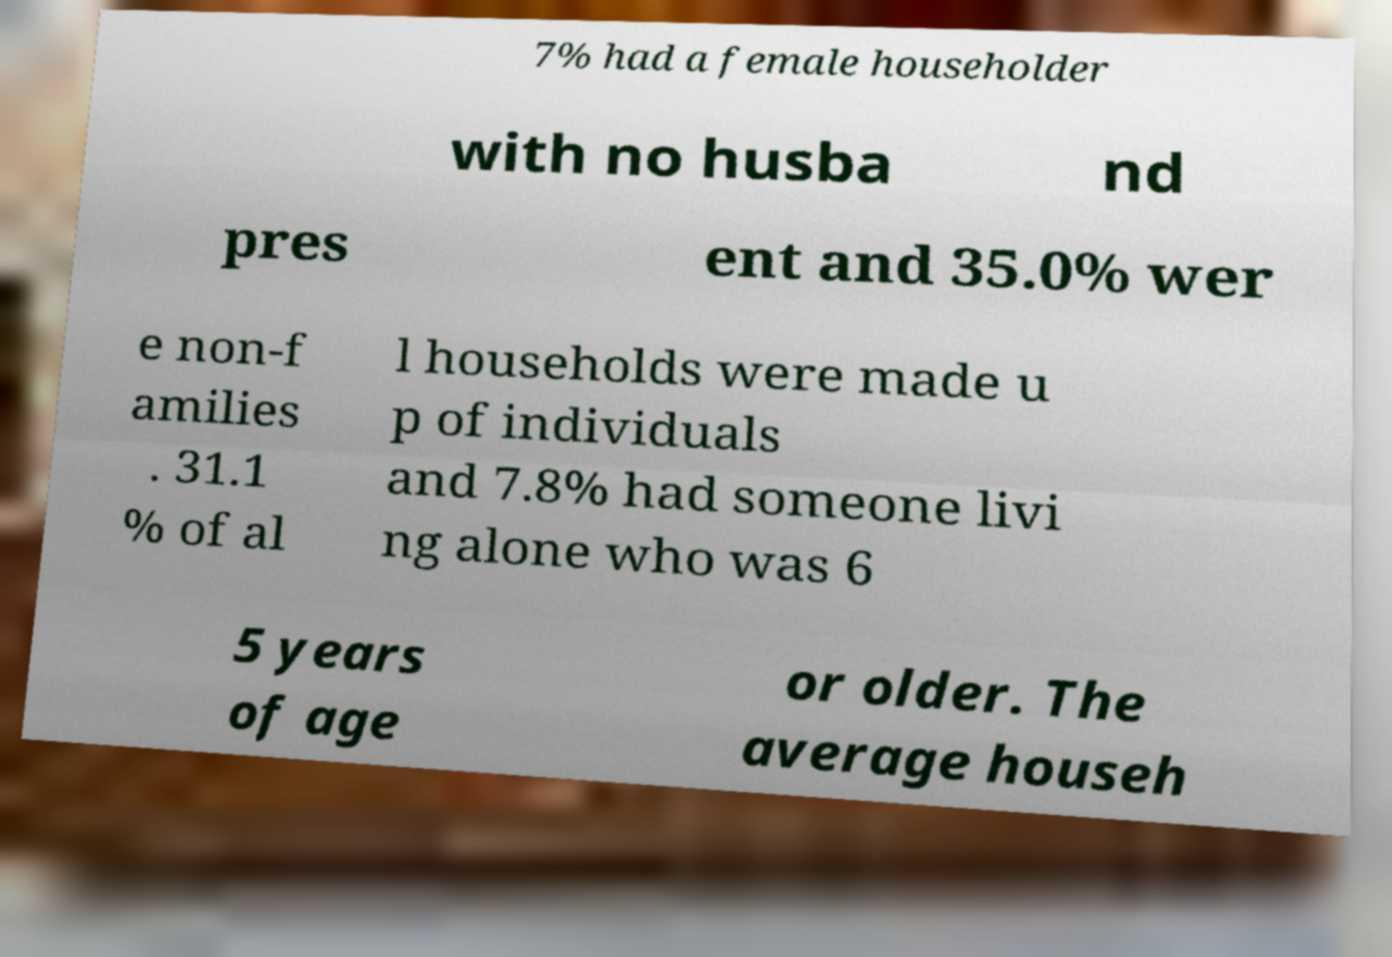Can you read and provide the text displayed in the image?This photo seems to have some interesting text. Can you extract and type it out for me? 7% had a female householder with no husba nd pres ent and 35.0% wer e non-f amilies . 31.1 % of al l households were made u p of individuals and 7.8% had someone livi ng alone who was 6 5 years of age or older. The average househ 